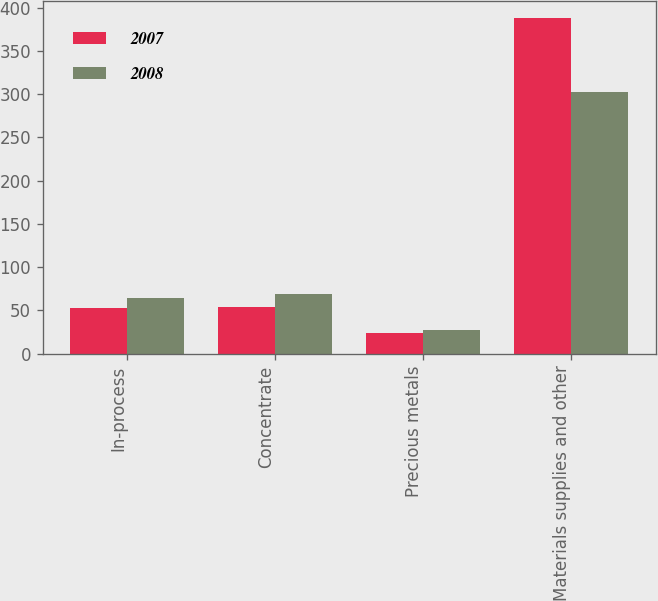Convert chart to OTSL. <chart><loc_0><loc_0><loc_500><loc_500><stacked_bar_chart><ecel><fcel>In-process<fcel>Concentrate<fcel>Precious metals<fcel>Materials supplies and other<nl><fcel>2007<fcel>53<fcel>54<fcel>24<fcel>388<nl><fcel>2008<fcel>64<fcel>69<fcel>27<fcel>303<nl></chart> 